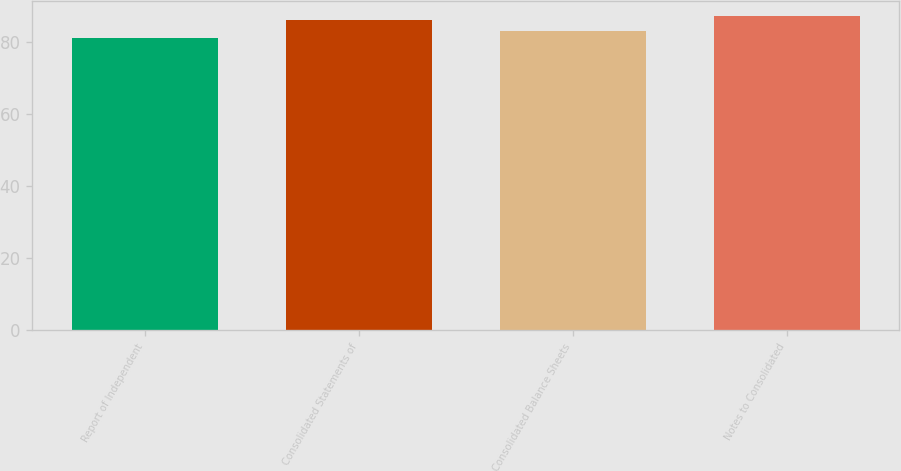<chart> <loc_0><loc_0><loc_500><loc_500><bar_chart><fcel>Report of Independent<fcel>Consolidated Statements of<fcel>Consolidated Balance Sheets<fcel>Notes to Consolidated<nl><fcel>81<fcel>86<fcel>83<fcel>87<nl></chart> 